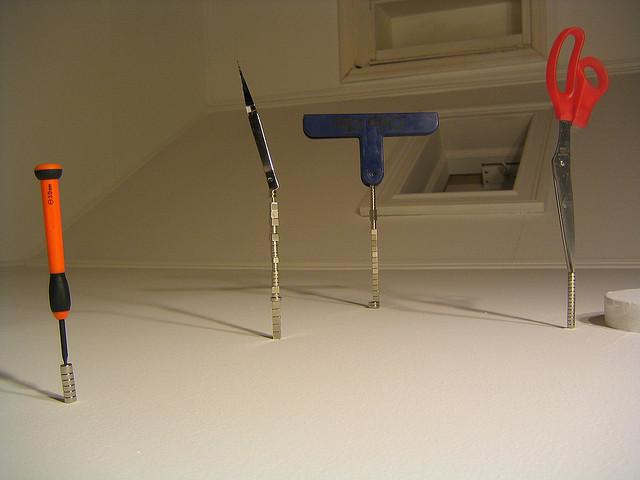What kind of tools are these?
Keep it brief. Household. Could any of these objects be used as weapons?
Answer briefly. Yes. Can you see a person here?
Give a very brief answer. No. 